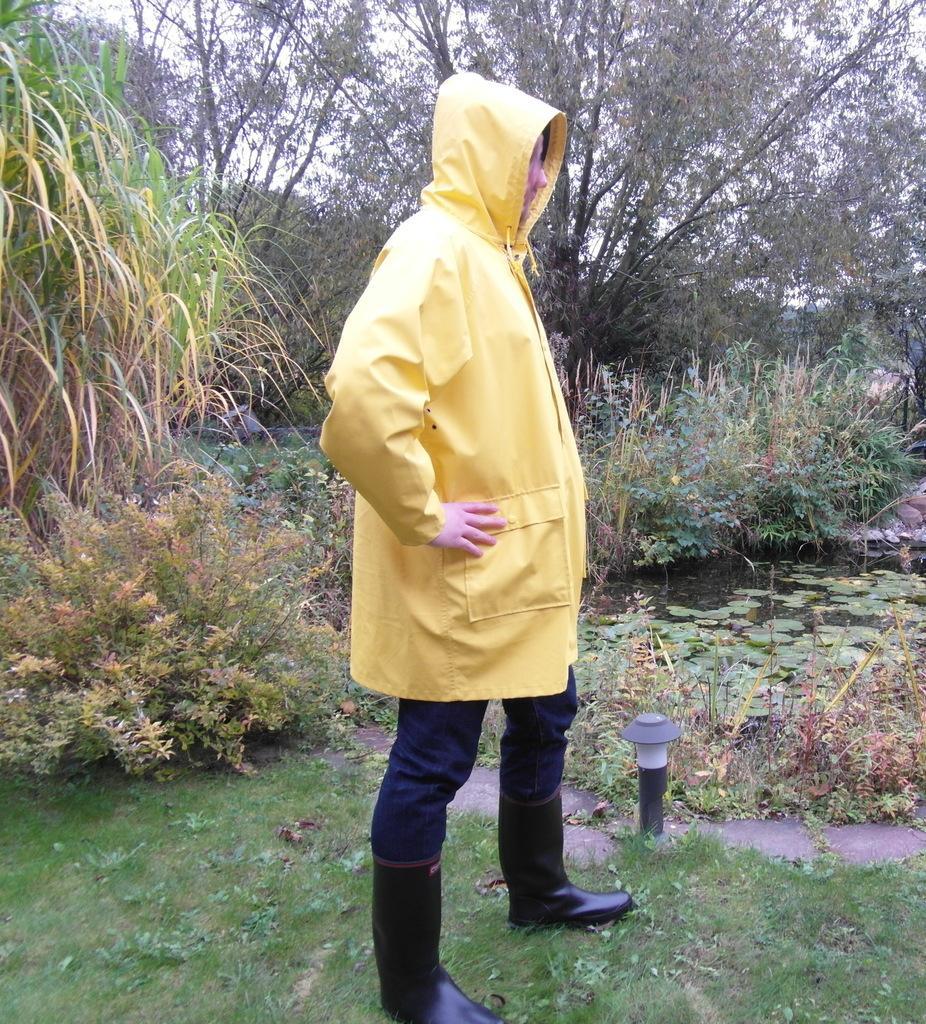Could you give a brief overview of what you see in this image? In this image, we can see a person standing and wearing a raincoat. There is a pond on the right side of the image. There are some plants in the middle of the image. In the background, there are some trees. 